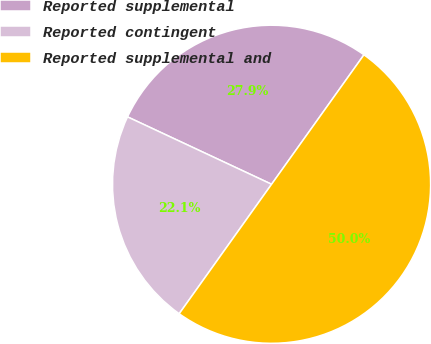Convert chart. <chart><loc_0><loc_0><loc_500><loc_500><pie_chart><fcel>Reported supplemental<fcel>Reported contingent<fcel>Reported supplemental and<nl><fcel>27.9%<fcel>22.1%<fcel>50.0%<nl></chart> 